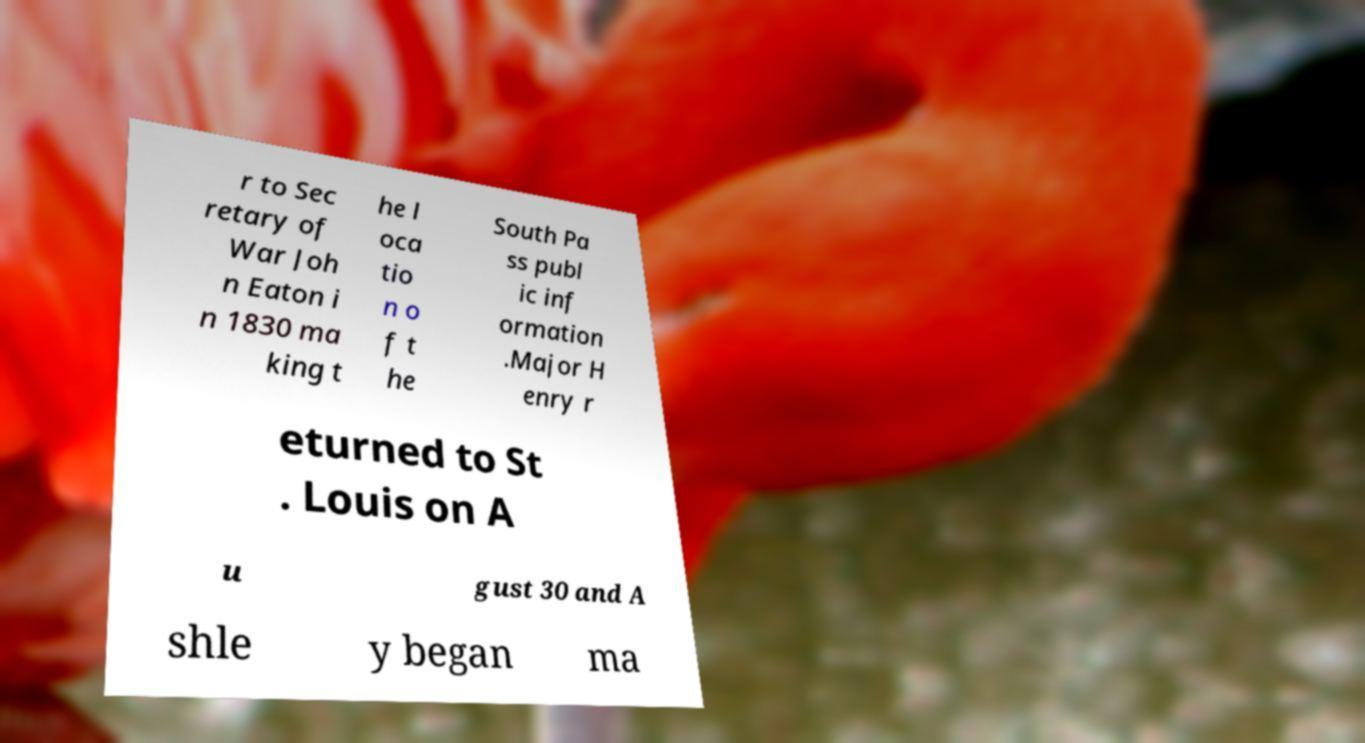Can you accurately transcribe the text from the provided image for me? r to Sec retary of War Joh n Eaton i n 1830 ma king t he l oca tio n o f t he South Pa ss publ ic inf ormation .Major H enry r eturned to St . Louis on A u gust 30 and A shle y began ma 